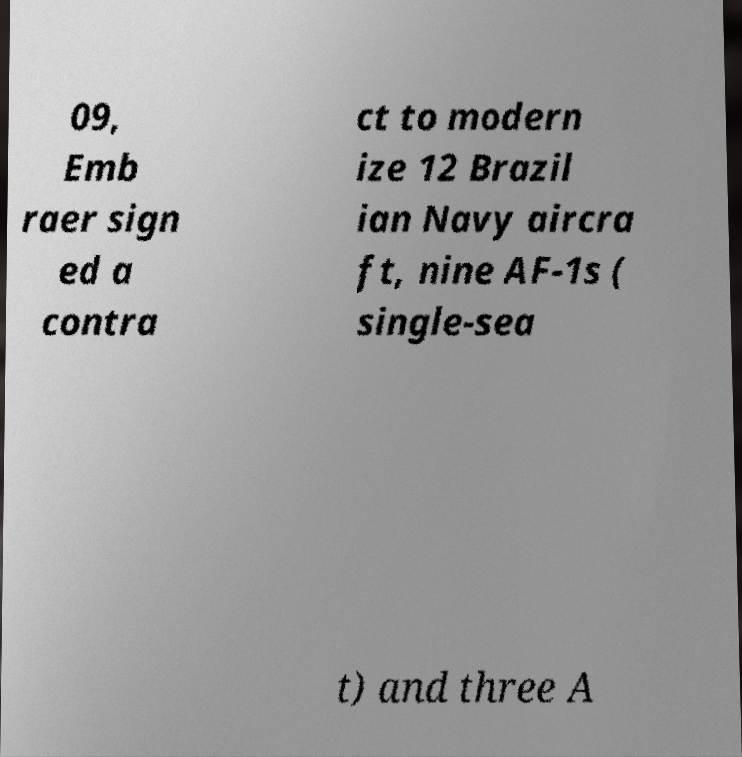Could you assist in decoding the text presented in this image and type it out clearly? 09, Emb raer sign ed a contra ct to modern ize 12 Brazil ian Navy aircra ft, nine AF-1s ( single-sea t) and three A 